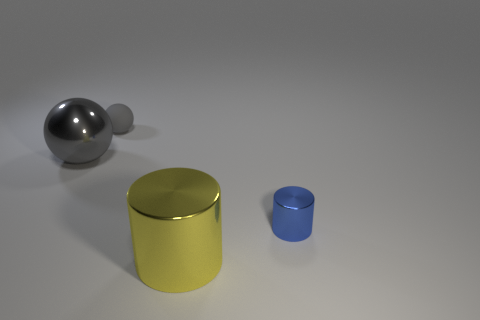Do the large metal object that is behind the yellow cylinder and the big object on the right side of the large sphere have the same color?
Your answer should be compact. No. There is a yellow shiny thing in front of the metallic object behind the tiny blue object; what shape is it?
Give a very brief answer. Cylinder. How many other things are the same color as the tiny cylinder?
Your answer should be compact. 0. Does the large object that is behind the small cylinder have the same material as the gray ball behind the gray metal object?
Keep it short and to the point. No. There is a shiny cylinder in front of the small blue cylinder; what is its size?
Offer a terse response. Large. There is a small thing that is the same shape as the big gray thing; what is it made of?
Give a very brief answer. Rubber. Is there any other thing that has the same size as the shiny sphere?
Keep it short and to the point. Yes. There is a big metal thing behind the blue shiny cylinder; what shape is it?
Provide a succinct answer. Sphere. What number of shiny things are the same shape as the tiny rubber thing?
Give a very brief answer. 1. Is the number of gray matte balls in front of the big shiny cylinder the same as the number of gray matte objects right of the tiny blue object?
Make the answer very short. Yes. 